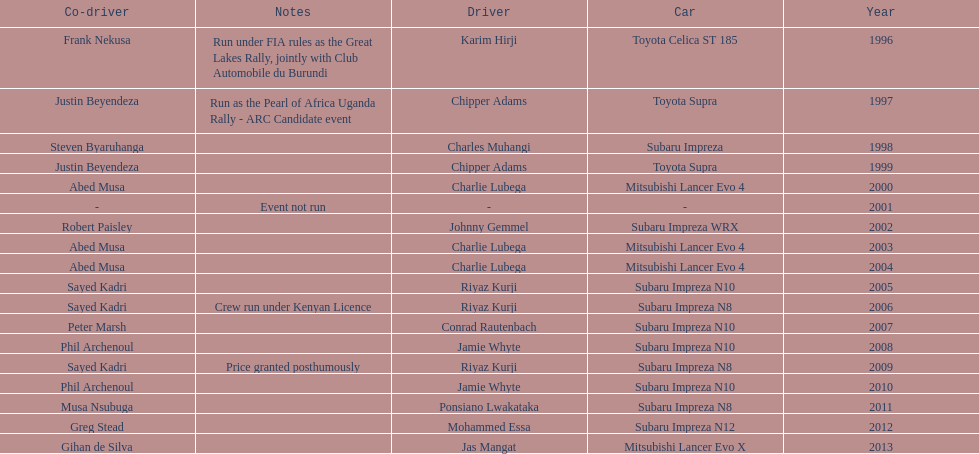Which was the only year that the event was not run? 2001. 